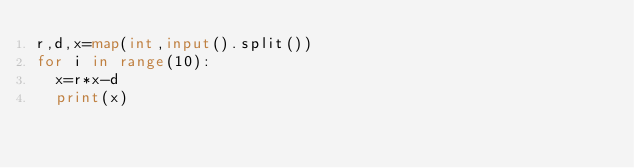Convert code to text. <code><loc_0><loc_0><loc_500><loc_500><_Python_>r,d,x=map(int,input().split())
for i in range(10):
  x=r*x-d
  print(x)</code> 